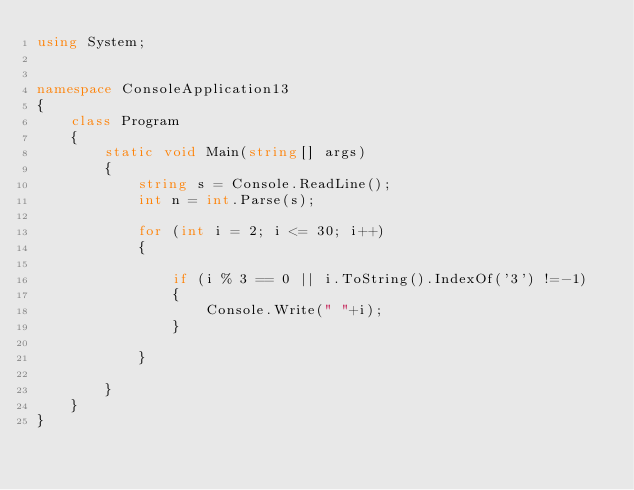Convert code to text. <code><loc_0><loc_0><loc_500><loc_500><_C#_>using System;


namespace ConsoleApplication13
{
    class Program
    {
        static void Main(string[] args)
        {
            string s = Console.ReadLine();
            int n = int.Parse(s);

            for (int i = 2; i <= 30; i++)
            {
                
                if (i % 3 == 0 || i.ToString().IndexOf('3') !=-1)
                {
                    Console.Write(" "+i);
                }

            }
        
        }
    }
}</code> 